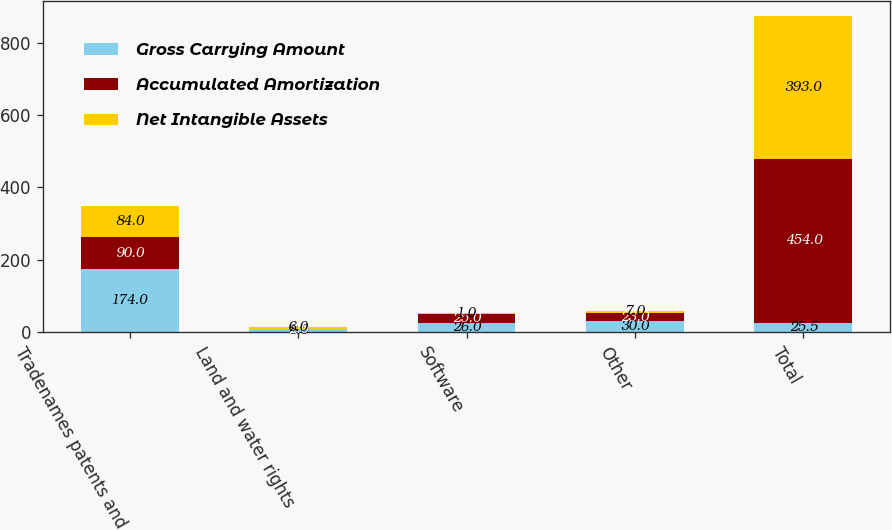Convert chart to OTSL. <chart><loc_0><loc_0><loc_500><loc_500><stacked_bar_chart><ecel><fcel>Tradenames patents and<fcel>Land and water rights<fcel>Software<fcel>Other<fcel>Total<nl><fcel>Gross Carrying Amount<fcel>174<fcel>8<fcel>26<fcel>30<fcel>25.5<nl><fcel>Accumulated Amortization<fcel>90<fcel>2<fcel>25<fcel>23<fcel>454<nl><fcel>Net Intangible Assets<fcel>84<fcel>6<fcel>1<fcel>7<fcel>393<nl></chart> 